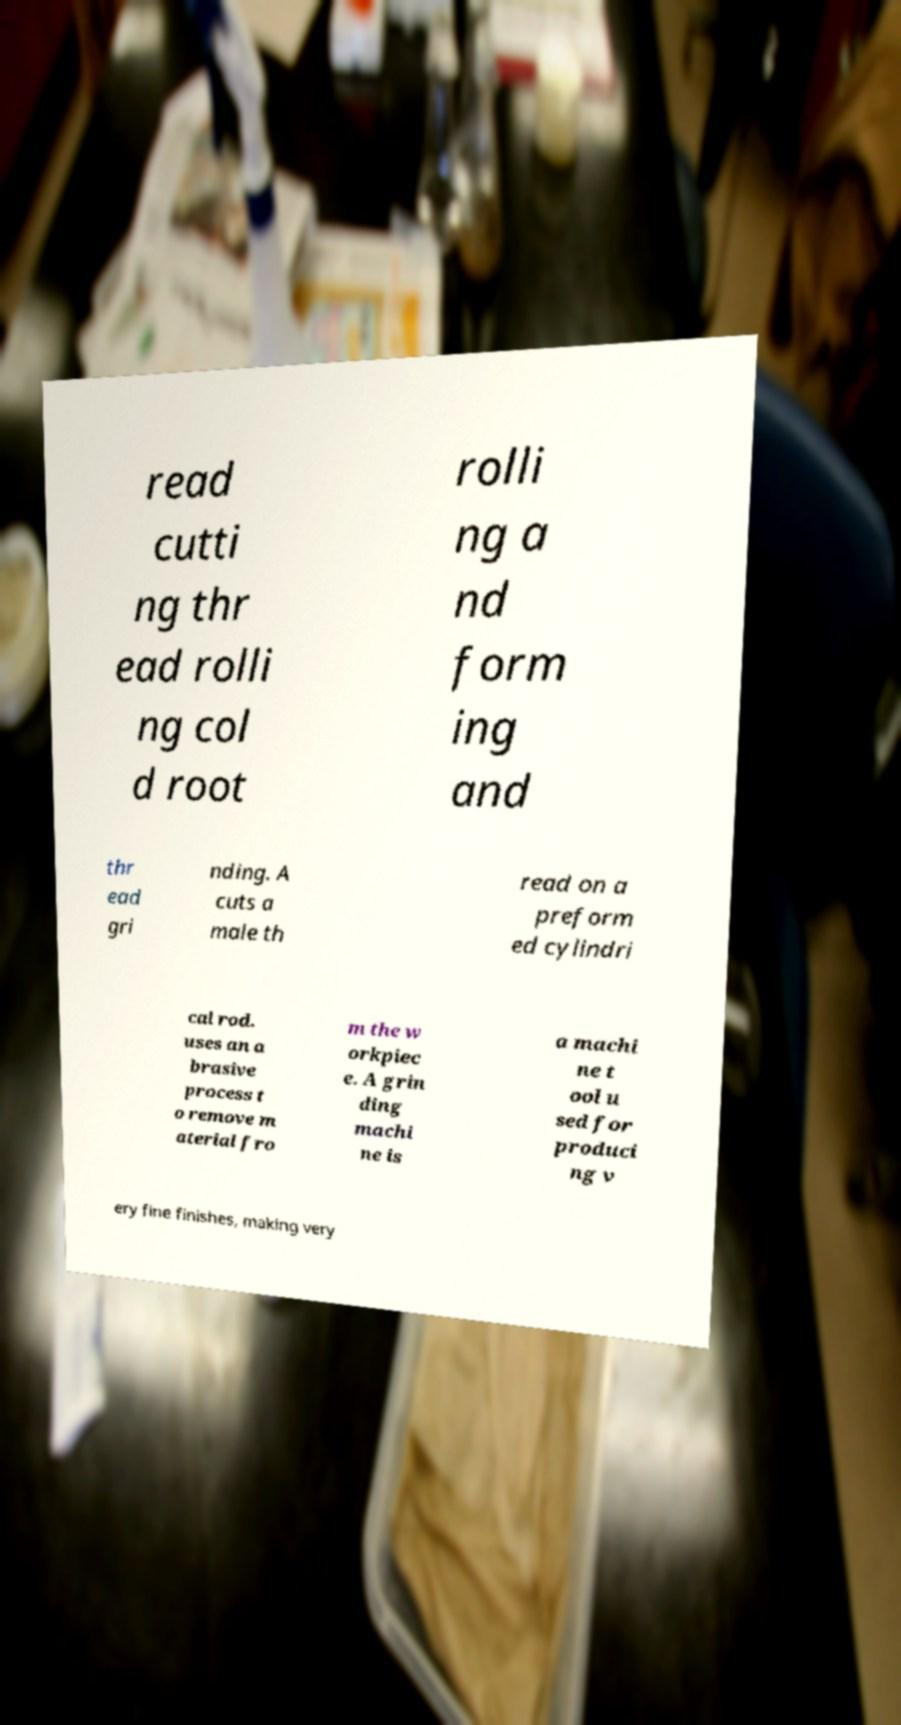What messages or text are displayed in this image? I need them in a readable, typed format. read cutti ng thr ead rolli ng col d root rolli ng a nd form ing and thr ead gri nding. A cuts a male th read on a preform ed cylindri cal rod. uses an a brasive process t o remove m aterial fro m the w orkpiec e. A grin ding machi ne is a machi ne t ool u sed for produci ng v ery fine finishes, making very 